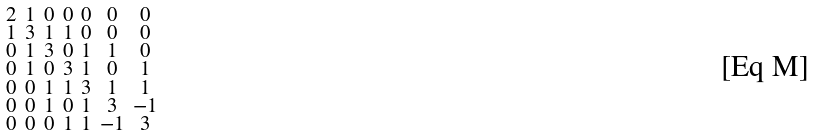<formula> <loc_0><loc_0><loc_500><loc_500>\begin{smallmatrix} 2 & 1 & 0 & 0 & 0 & 0 & 0 \\ 1 & 3 & 1 & 1 & 0 & 0 & 0 \\ 0 & 1 & 3 & 0 & 1 & 1 & 0 \\ 0 & 1 & 0 & 3 & 1 & 0 & 1 \\ 0 & 0 & 1 & 1 & 3 & 1 & 1 \\ 0 & 0 & 1 & 0 & 1 & 3 & - 1 \\ 0 & 0 & 0 & 1 & 1 & - 1 & 3 \end{smallmatrix}</formula> 